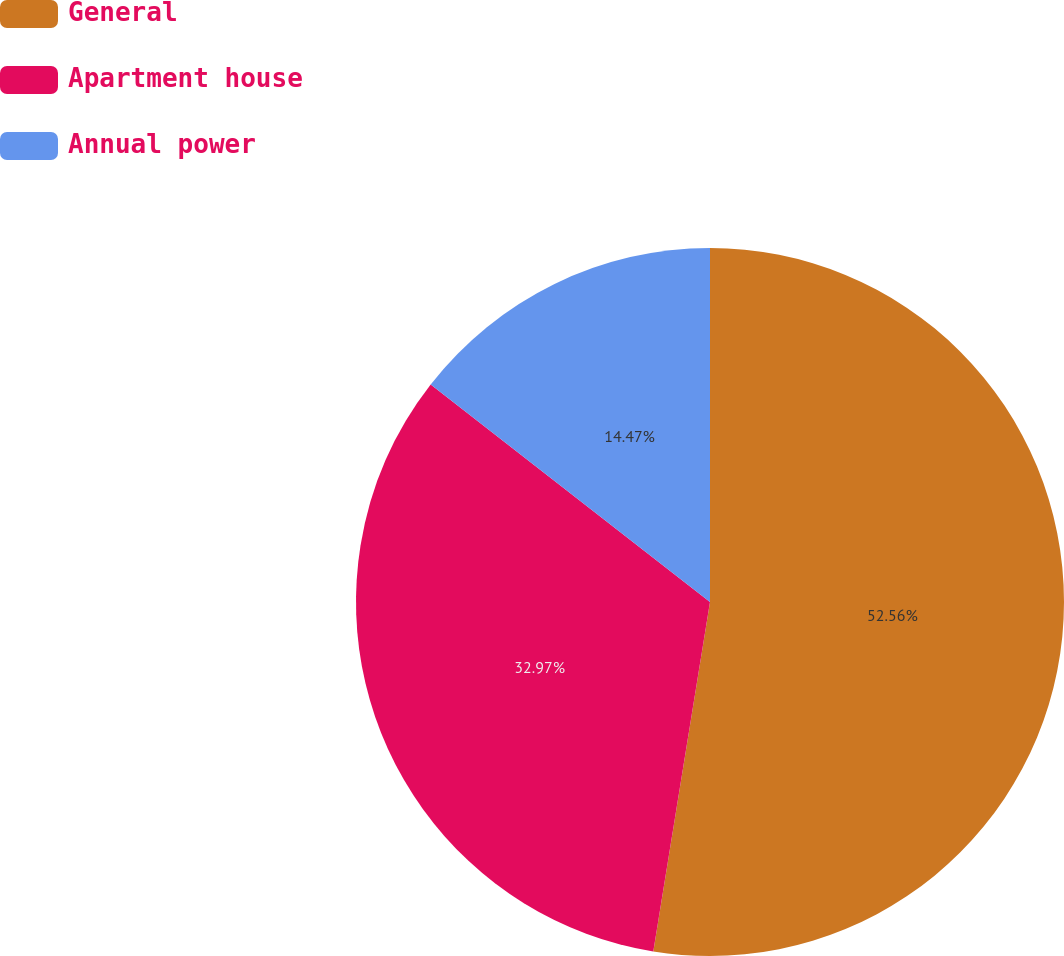Convert chart to OTSL. <chart><loc_0><loc_0><loc_500><loc_500><pie_chart><fcel>General<fcel>Apartment house<fcel>Annual power<nl><fcel>52.56%<fcel>32.97%<fcel>14.47%<nl></chart> 